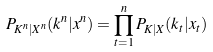<formula> <loc_0><loc_0><loc_500><loc_500>P _ { K ^ { n } | X ^ { n } } ( k ^ { n } | x ^ { n } ) = \prod _ { t = 1 } ^ { n } P _ { K | X } ( k _ { t } | x _ { t } )</formula> 